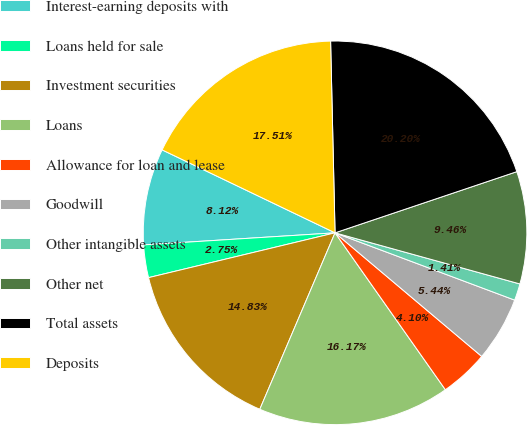Convert chart. <chart><loc_0><loc_0><loc_500><loc_500><pie_chart><fcel>Interest-earning deposits with<fcel>Loans held for sale<fcel>Investment securities<fcel>Loans<fcel>Allowance for loan and lease<fcel>Goodwill<fcel>Other intangible assets<fcel>Other net<fcel>Total assets<fcel>Deposits<nl><fcel>8.12%<fcel>2.75%<fcel>14.83%<fcel>16.17%<fcel>4.1%<fcel>5.44%<fcel>1.41%<fcel>9.46%<fcel>20.2%<fcel>17.51%<nl></chart> 